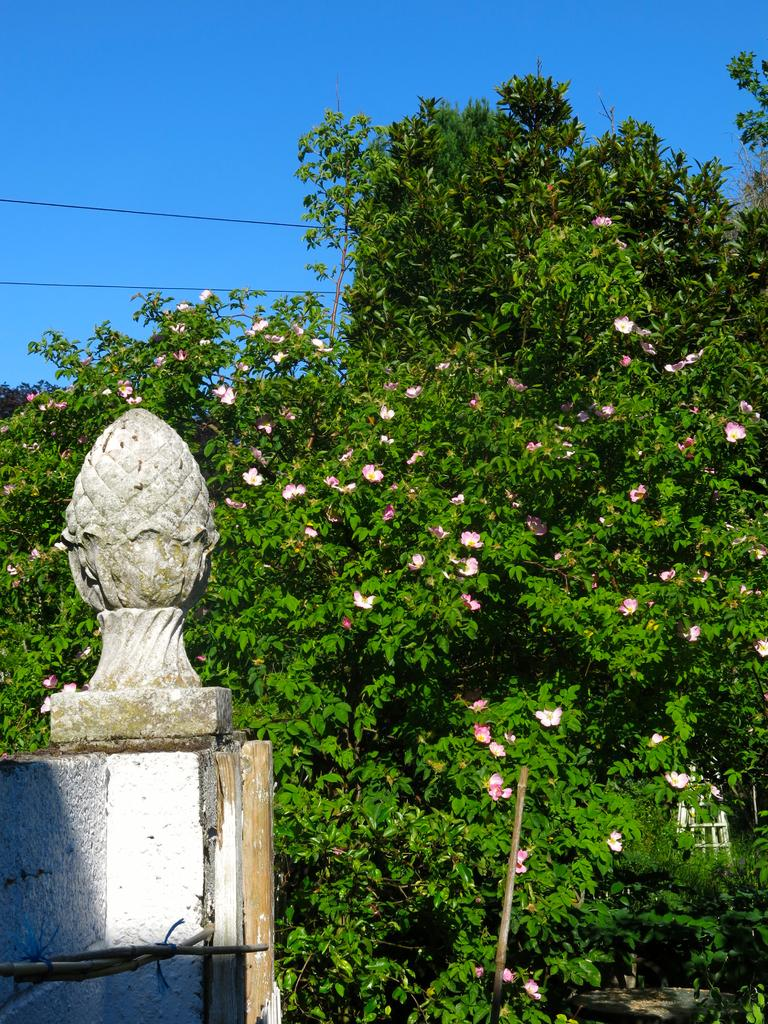What type of structure can be seen on the wall in the image? There is a rock structure on the wall in the image. What can be seen in the background of the image? There are trees, flowers, and the sky visible in the background of the image. How many bubbles can be seen floating near the rock structure in the image? There are no bubbles present in the image. What type of pest can be seen crawling on the rock structure in the image? There is no pest visible in the image; it features a rock structure on the wall. 